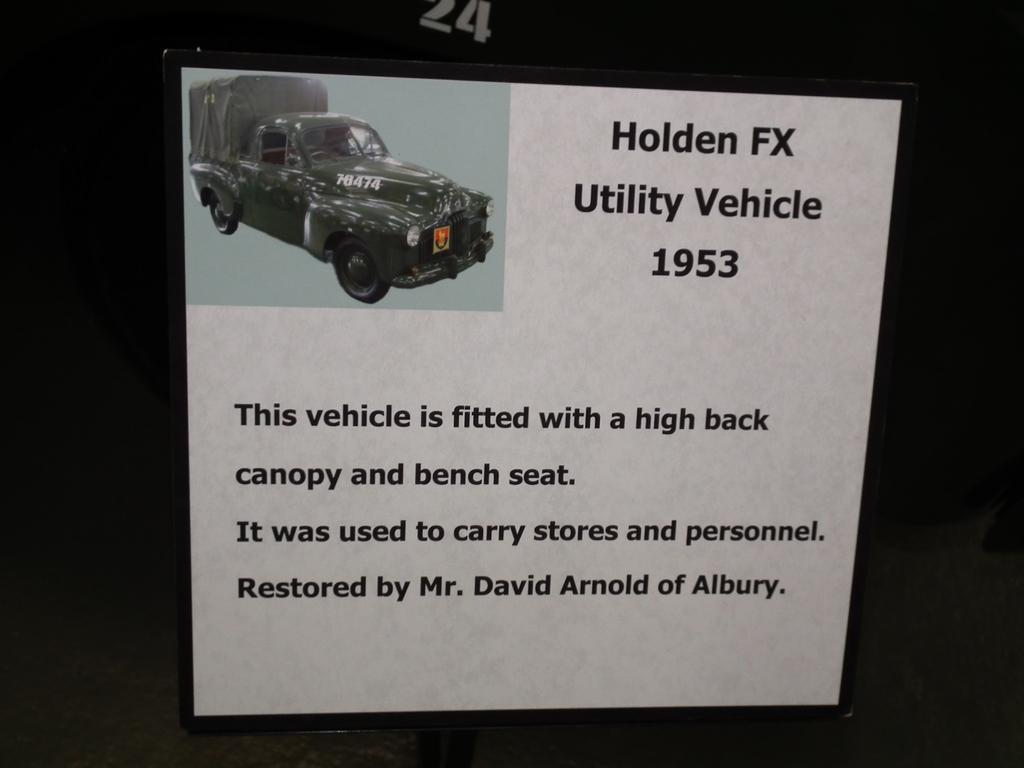Can you describe this image briefly? In the center of the image we can see a board. On the board, we can see a poster. On the poster, we can see a vehicle and some text. At the top of the image, we can see two numbers. And we can see the dark background. 